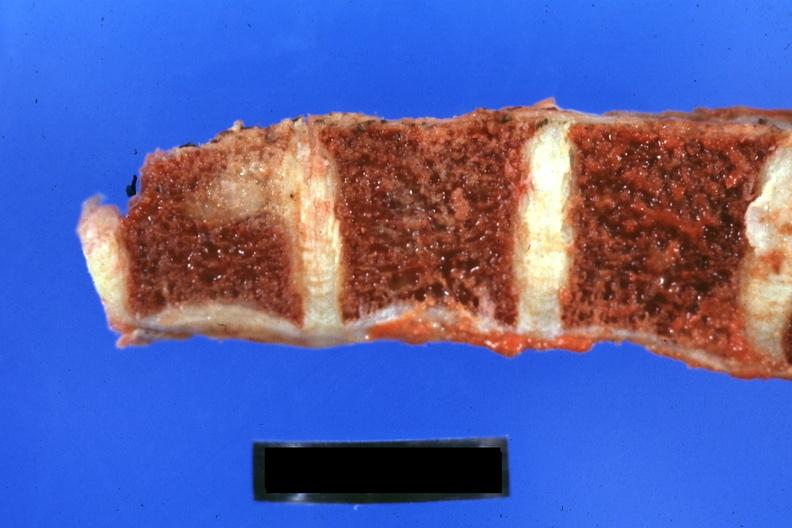how does this image show close-up of vertebra?
Answer the question using a single word or phrase. With obvious metastatic lesion 44yobfadenocarcinoma lung giant cell type occurring 25 years after she was treat-ed for hodgkins disease 